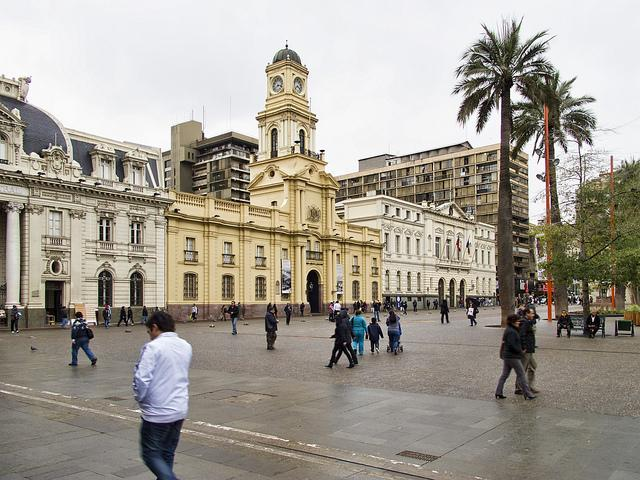What location are people strolling in? courtyard 